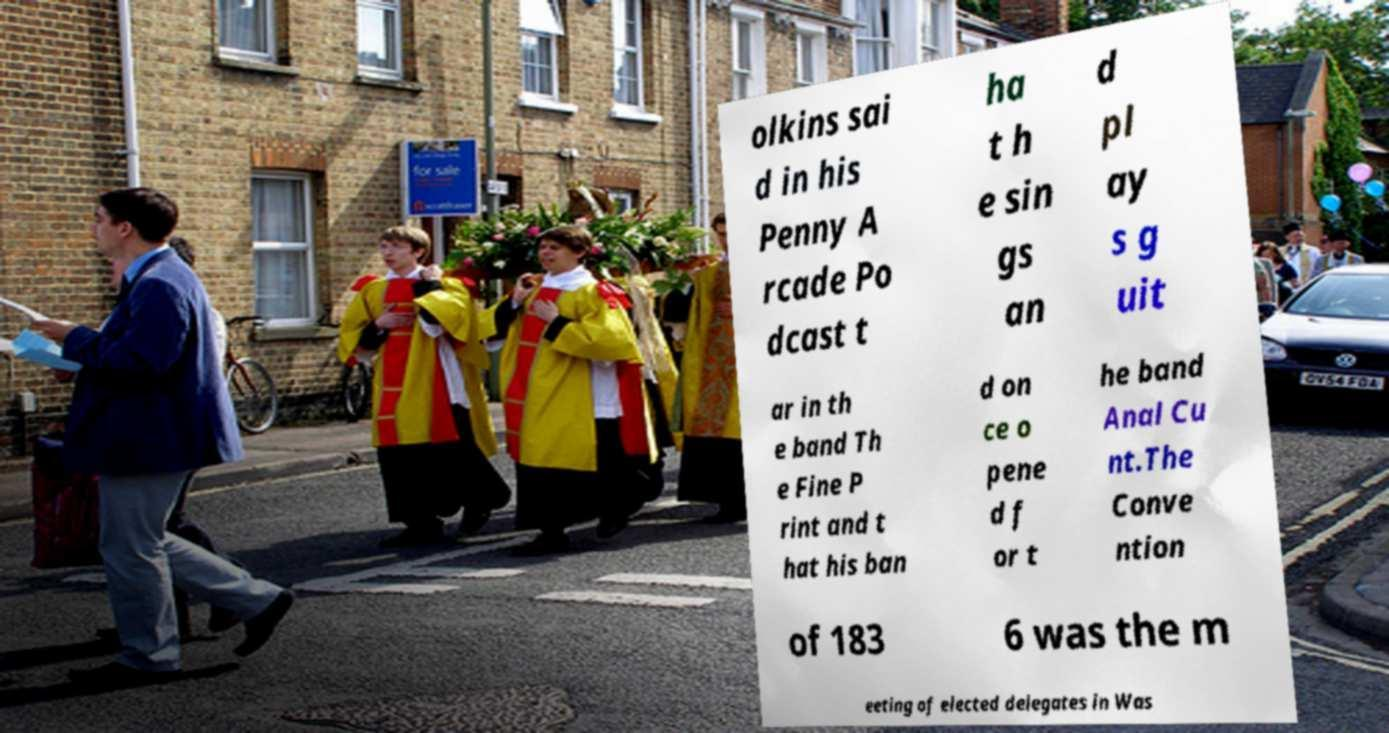There's text embedded in this image that I need extracted. Can you transcribe it verbatim? olkins sai d in his Penny A rcade Po dcast t ha t h e sin gs an d pl ay s g uit ar in th e band Th e Fine P rint and t hat his ban d on ce o pene d f or t he band Anal Cu nt.The Conve ntion of 183 6 was the m eeting of elected delegates in Was 